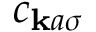Convert formula to latex. <formula><loc_0><loc_0><loc_500><loc_500>c _ { k a \sigma }</formula> 